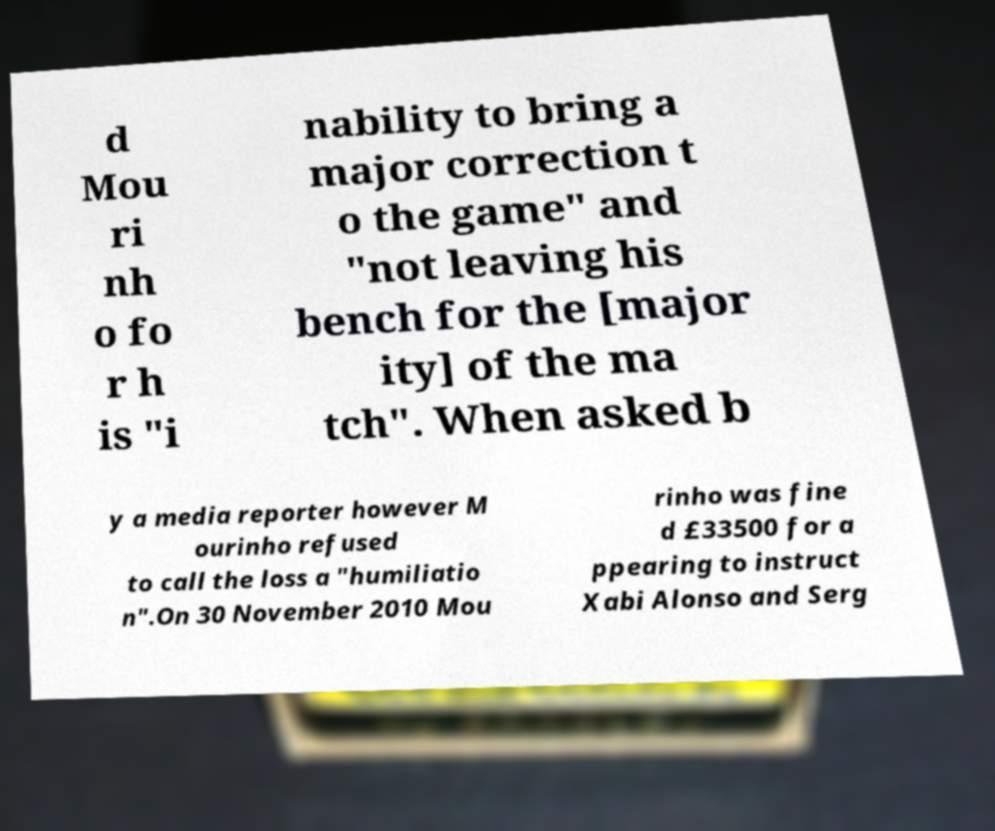What messages or text are displayed in this image? I need them in a readable, typed format. d Mou ri nh o fo r h is "i nability to bring a major correction t o the game" and "not leaving his bench for the [major ity] of the ma tch". When asked b y a media reporter however M ourinho refused to call the loss a "humiliatio n".On 30 November 2010 Mou rinho was fine d £33500 for a ppearing to instruct Xabi Alonso and Serg 